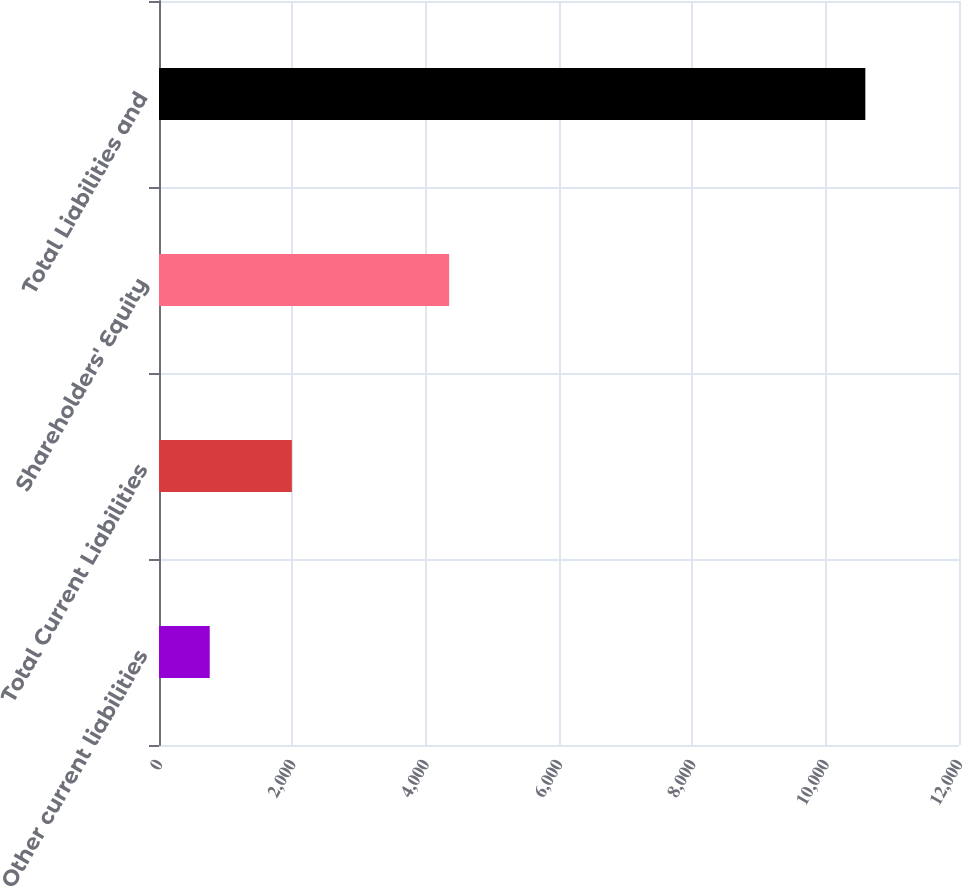Convert chart. <chart><loc_0><loc_0><loc_500><loc_500><bar_chart><fcel>Other current liabilities<fcel>Total Current Liabilities<fcel>Shareholders' Equity<fcel>Total Liabilities and<nl><fcel>761<fcel>1993<fcel>4352<fcel>10595<nl></chart> 